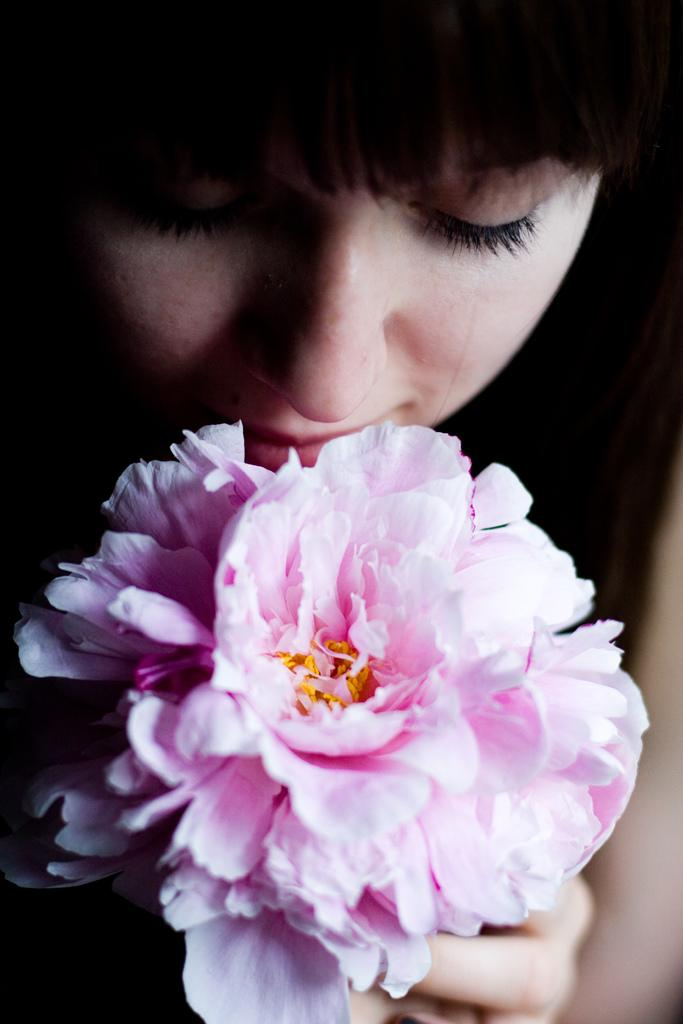Who is present in the image? There is a woman in the image. What is the woman holding in the image? The woman is holding a flower. Can you describe the colors of the flower? The flower has light pink and yellow colors. How many apples are on the cactus in the image? There is no cactus or apples present in the image. 